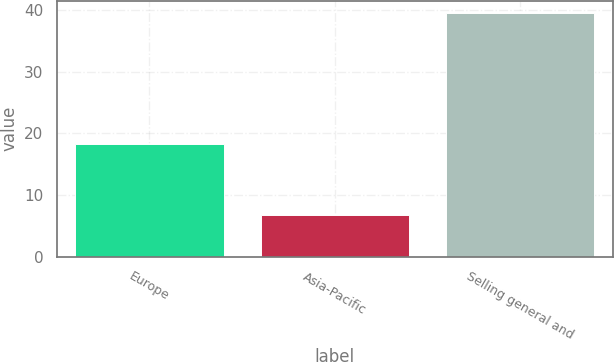Convert chart. <chart><loc_0><loc_0><loc_500><loc_500><bar_chart><fcel>Europe<fcel>Asia-Pacific<fcel>Selling general and<nl><fcel>18.3<fcel>6.8<fcel>39.5<nl></chart> 